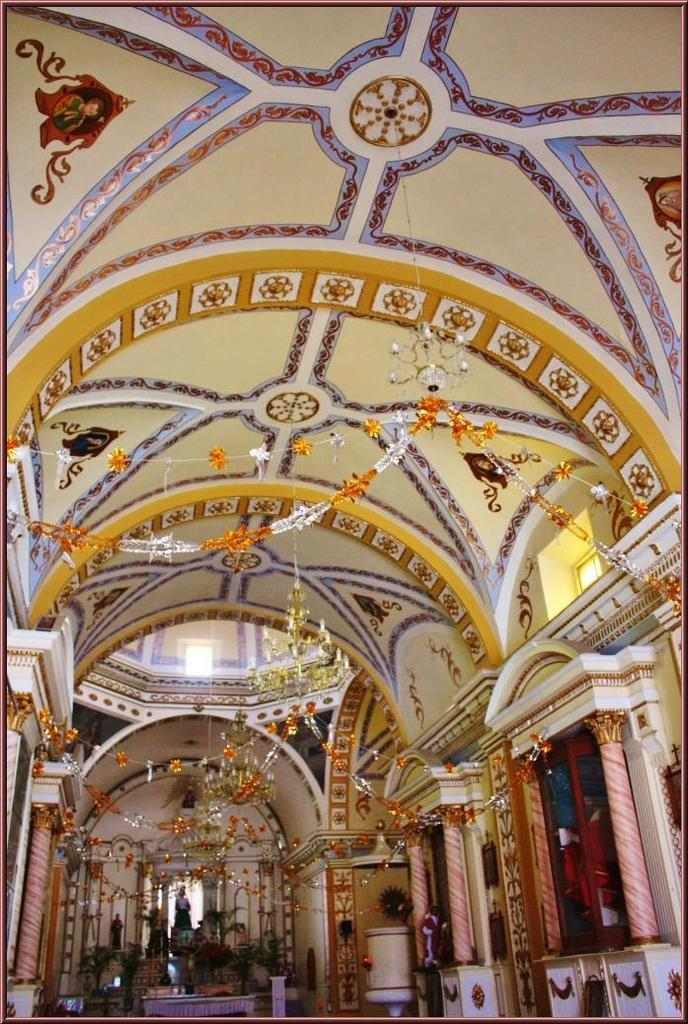What part of a building is shown in the image? The image shows the inner part of a building. What can be seen inside the building? There are podiums and decorative objects inside the building. Are there any specific features or objects inside the building? Yes, there are statues inside the building. How does the rice contribute to the decoration of the building in the image? There is no rice present in the image, so it cannot contribute to the decoration. 